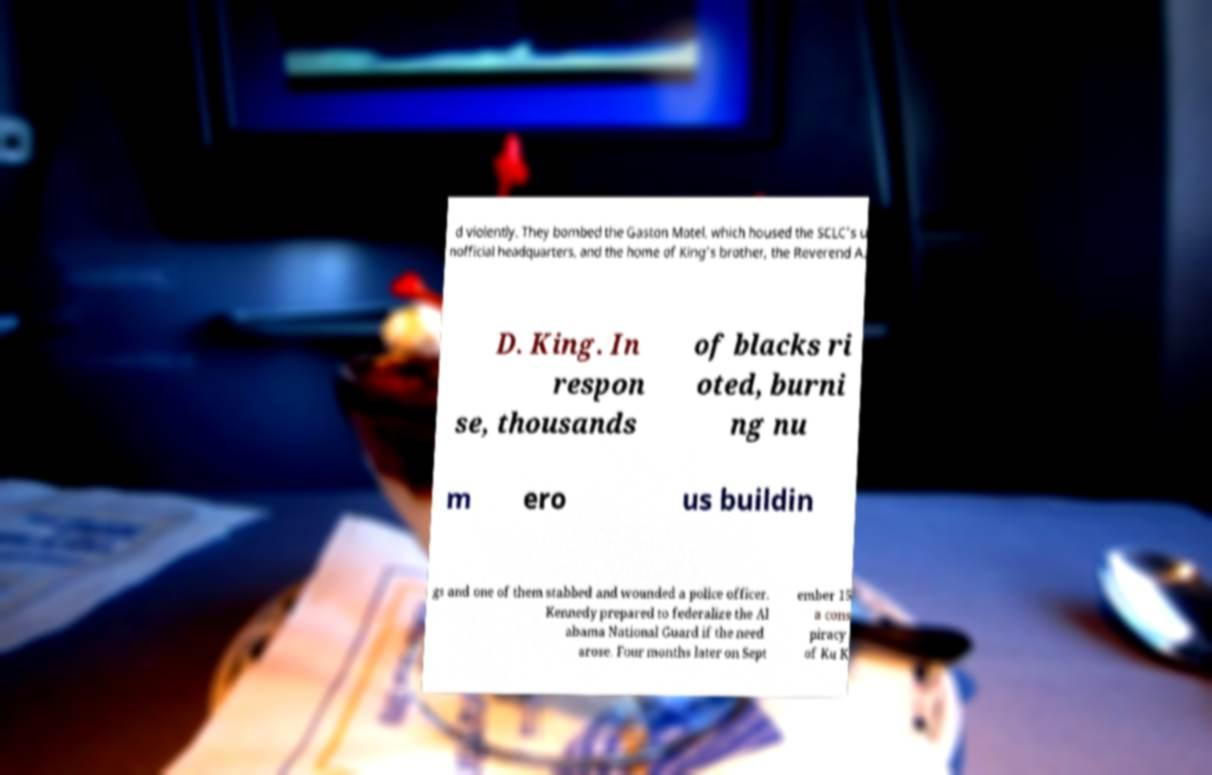Please identify and transcribe the text found in this image. d violently. They bombed the Gaston Motel, which housed the SCLC's u nofficial headquarters, and the home of King's brother, the Reverend A. D. King. In respon se, thousands of blacks ri oted, burni ng nu m ero us buildin gs and one of them stabbed and wounded a police officer. Kennedy prepared to federalize the Al abama National Guard if the need arose. Four months later on Sept ember 15 a cons piracy of Ku K 